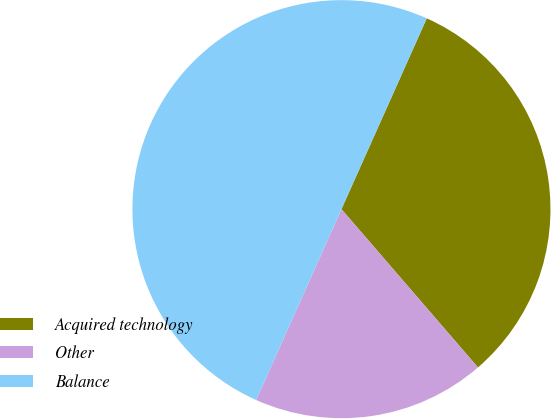Convert chart to OTSL. <chart><loc_0><loc_0><loc_500><loc_500><pie_chart><fcel>Acquired technology<fcel>Other<fcel>Balance<nl><fcel>31.98%<fcel>18.02%<fcel>50.0%<nl></chart> 